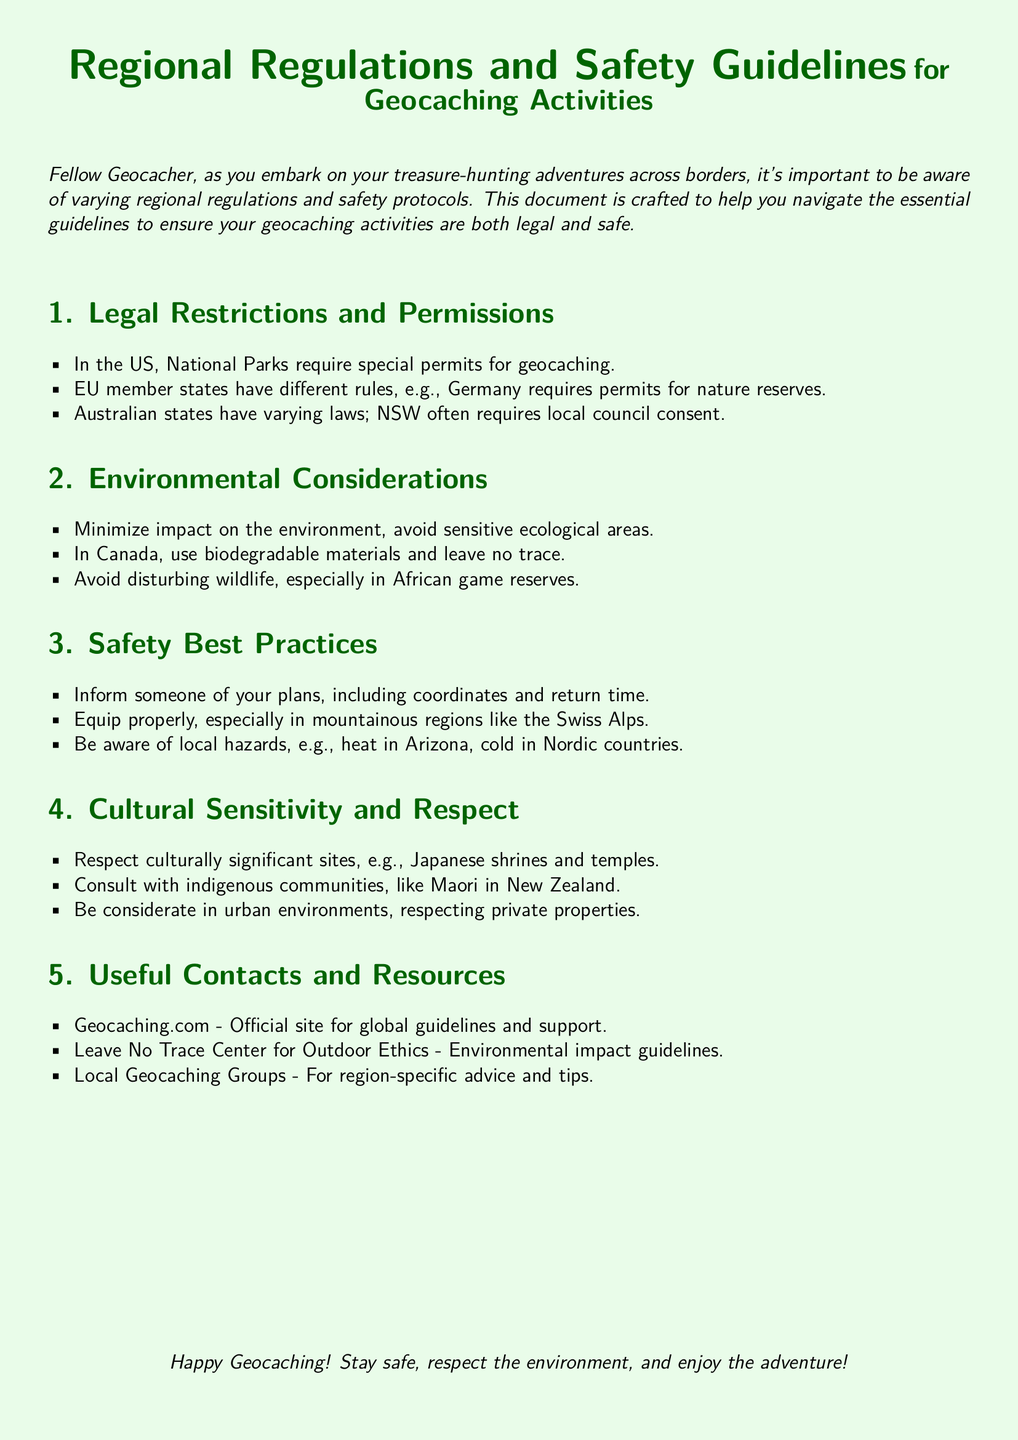What are the regulations for geocaching in National Parks in the US? National Parks require special permits for geocaching according to the document.
Answer: special permits What environmental practices are recommended in Canada? The document states that in Canada, geocachers should use biodegradable materials and leave no trace.
Answer: biodegradable materials and leave no trace What should you do before going geocaching? You should inform someone of your plans, including coordinates and return time, as stated in the safety guidelines.
Answer: inform someone of your plans Which organization provides global guidelines for geocaching? The document lists Geocaching.com as the official site for global guidelines and support.
Answer: Geocaching.com What is a critical consideration when caching in respect to cultural sites? Respecting culturally significant sites is emphasized in the document, such as Japanese shrines and temples.
Answer: Respect culturally significant sites Which Australian state often requires local council consent for geocaching? The document indicates that NSW (New South Wales) often requires local council consent for geocaching.
Answer: NSW What safety equipment is particularly important in mountainous regions? The document suggests equipping properly, especially in mountainous regions like the Swiss Alps.
Answer: equip properly How does the document suggest approaching indigenous communities? It advises consulting with indigenous communities, like Maori in New Zealand.
Answer: Consult with indigenous communities 